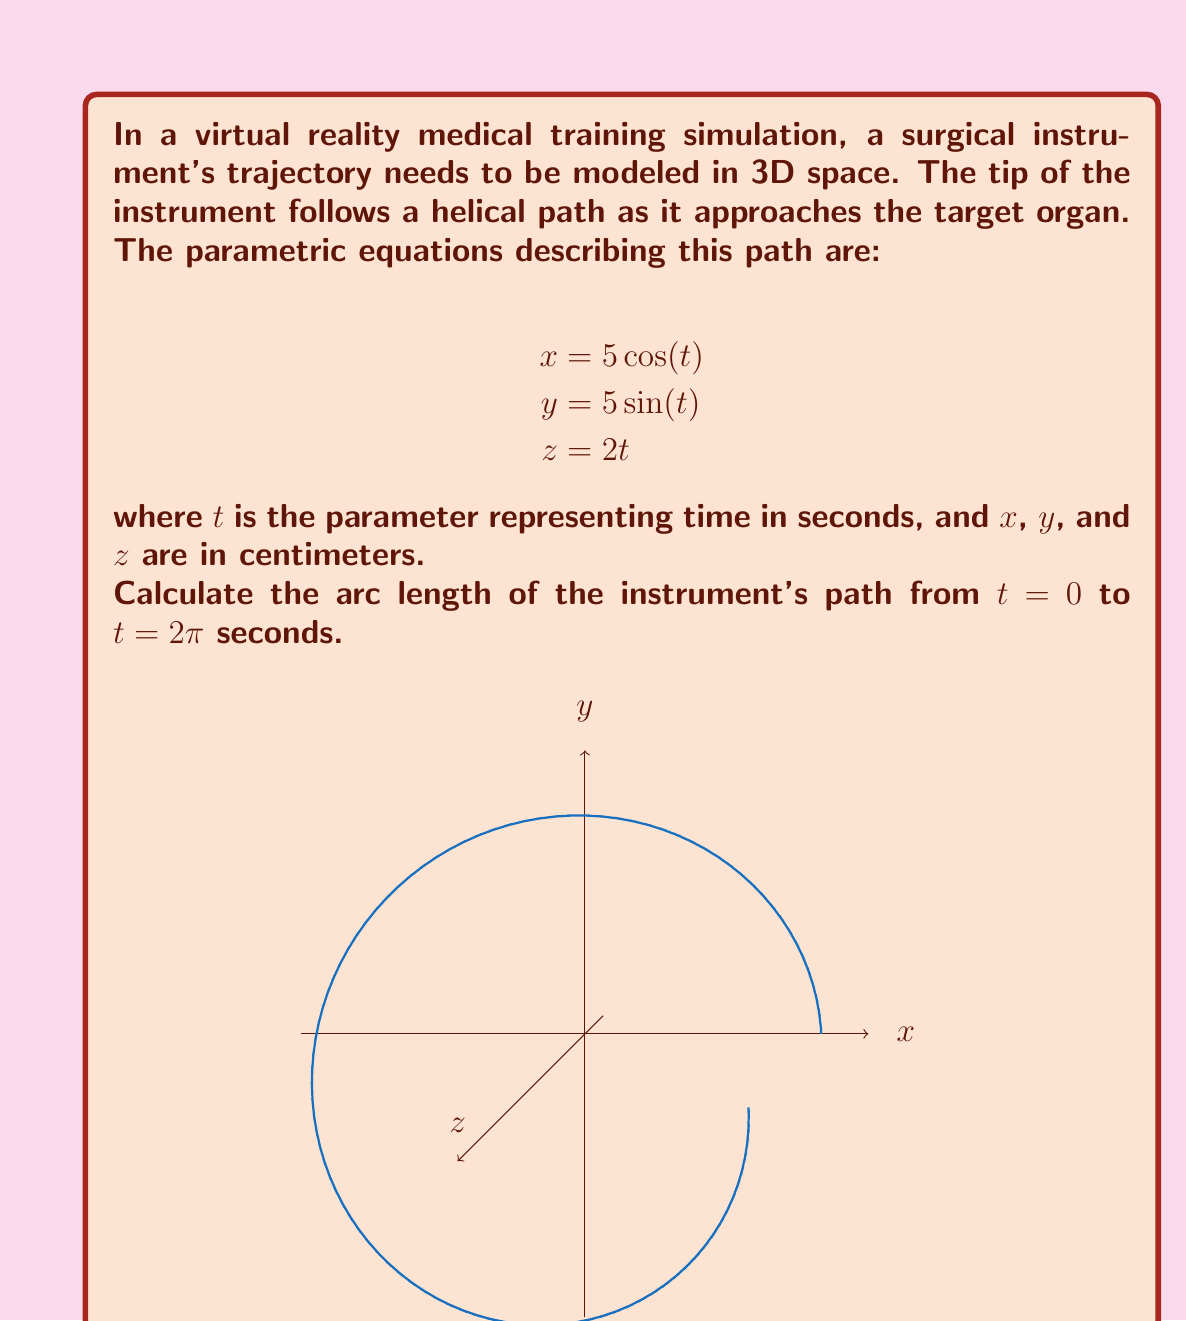Give your solution to this math problem. To find the arc length of a parametric curve, we use the formula:

$$L = \int_a^b \sqrt{\left(\frac{dx}{dt}\right)^2 + \left(\frac{dy}{dt}\right)^2 + \left(\frac{dz}{dt}\right)^2} dt$$

Step 1: Calculate the derivatives
$$\frac{dx}{dt} = -5\sin(t)$$
$$\frac{dy}{dt} = 5\cos(t)$$
$$\frac{dz}{dt} = 2$$

Step 2: Substitute into the arc length formula
$$L = \int_0^{2\pi} \sqrt{(-5\sin(t))^2 + (5\cos(t))^2 + 2^2} dt$$

Step 3: Simplify under the square root
$$L = \int_0^{2\pi} \sqrt{25\sin^2(t) + 25\cos^2(t) + 4} dt$$
$$L = \int_0^{2\pi} \sqrt{25(\sin^2(t) + \cos^2(t)) + 4} dt$$
$$L = \int_0^{2\pi} \sqrt{25 + 4} dt$$ (since $\sin^2(t) + \cos^2(t) = 1$)
$$L = \int_0^{2\pi} \sqrt{29} dt$$

Step 4: Evaluate the integral
$$L = \sqrt{29} \int_0^{2\pi} dt = \sqrt{29} [t]_0^{2\pi} = 2\pi\sqrt{29}$$

Therefore, the arc length of the instrument's path is $2\pi\sqrt{29}$ centimeters.
Answer: $2\pi\sqrt{29}$ cm 